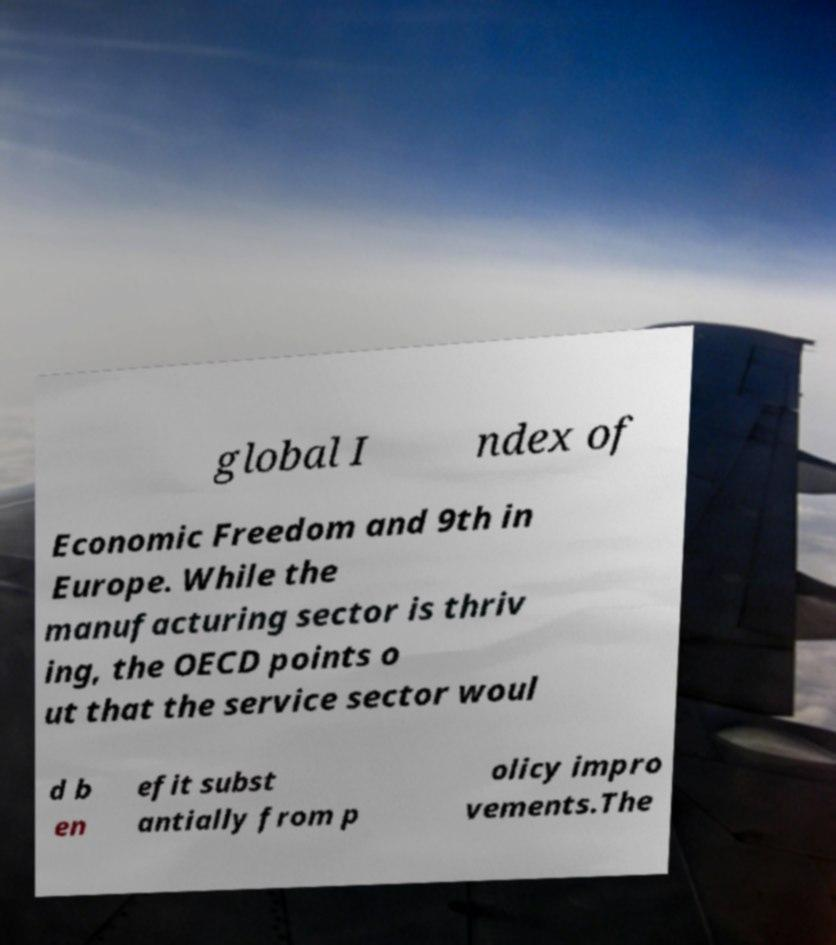What messages or text are displayed in this image? I need them in a readable, typed format. global I ndex of Economic Freedom and 9th in Europe. While the manufacturing sector is thriv ing, the OECD points o ut that the service sector woul d b en efit subst antially from p olicy impro vements.The 